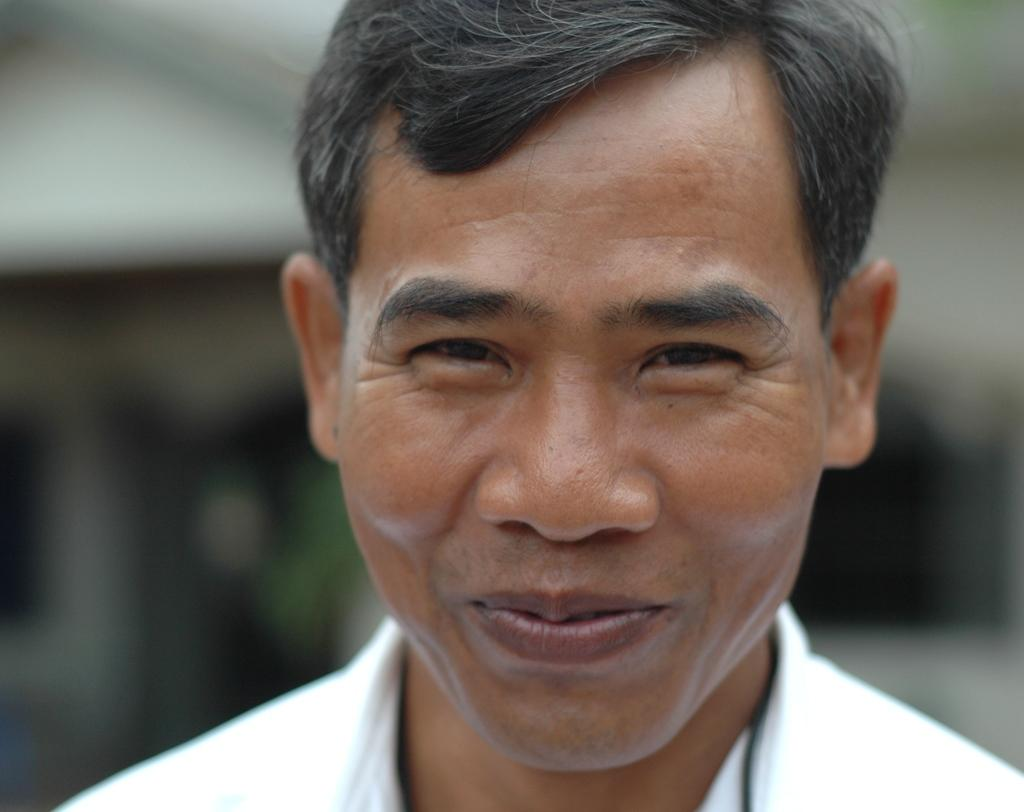What is present in the image? There is a person in the image. How is the person's facial expression? The person is smiling. What type of clothing is the person wearing? The person is wearing a white t-shirt. What type of quiver is the person holding in the image? There is no quiver present in the image; the person is only wearing a white t-shirt and smiling. 